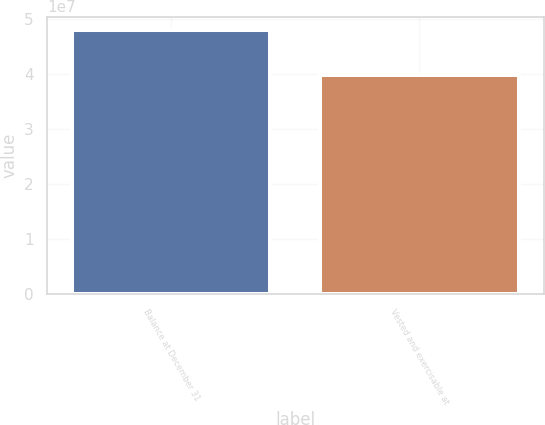Convert chart to OTSL. <chart><loc_0><loc_0><loc_500><loc_500><bar_chart><fcel>Balance at December 31<fcel>Vested and exercisable at<nl><fcel>4.80147e+07<fcel>3.97251e+07<nl></chart> 